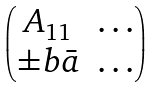Convert formula to latex. <formula><loc_0><loc_0><loc_500><loc_500>\begin{pmatrix} A _ { 1 1 } & \dots \\ \pm b { \bar { a } } & \dots \\ \end{pmatrix}</formula> 